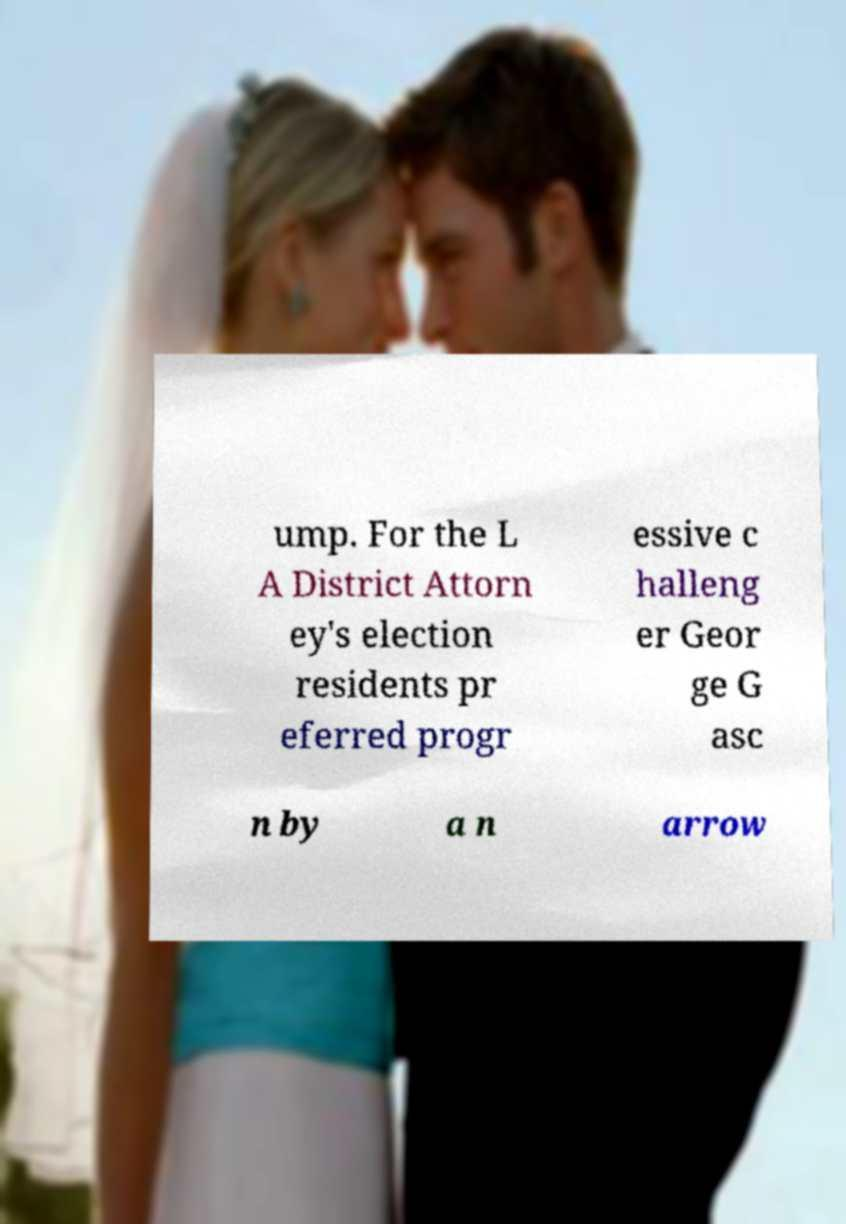Please read and relay the text visible in this image. What does it say? ump. For the L A District Attorn ey's election residents pr eferred progr essive c halleng er Geor ge G asc n by a n arrow 